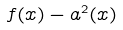<formula> <loc_0><loc_0><loc_500><loc_500>f ( x ) - a ^ { 2 } ( x )</formula> 